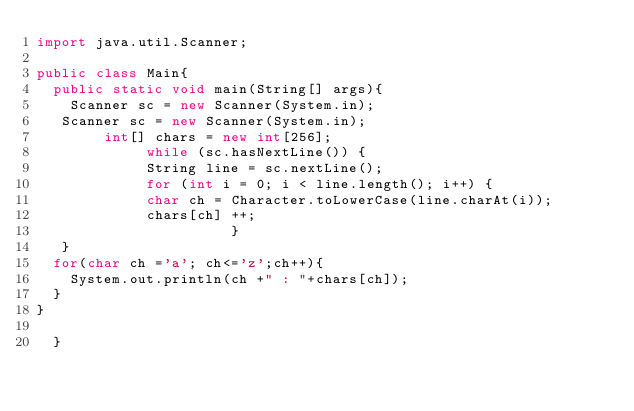Convert code to text. <code><loc_0><loc_0><loc_500><loc_500><_Java_>import java.util.Scanner;

public class Main{
	public static void main(String[] args){
		Scanner sc = new Scanner(System.in);
	 Scanner sc = new Scanner(System.in);
	      int[] chars = new int[256];
	           while (sc.hasNextLine()) {
	           String line = sc.nextLine();
	           for (int i = 0; i < line.length(); i++) {
	           char ch = Character.toLowerCase(line.charAt(i));
	           chars[ch] ++;
	                     }     
	 } 	
	for(char ch ='a'; ch<='z';ch++){
		System.out.println(ch +" : "+chars[ch]);
	}
}

	}</code> 